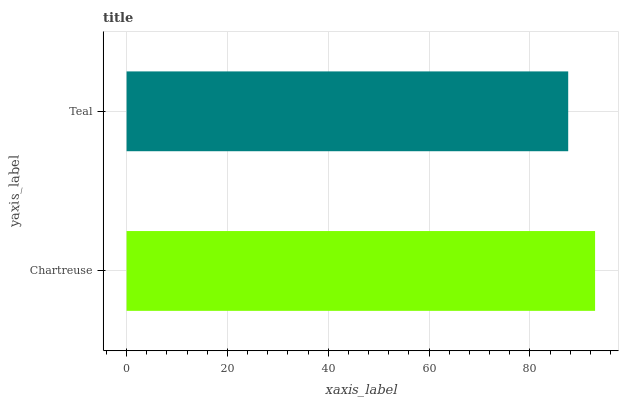Is Teal the minimum?
Answer yes or no. Yes. Is Chartreuse the maximum?
Answer yes or no. Yes. Is Teal the maximum?
Answer yes or no. No. Is Chartreuse greater than Teal?
Answer yes or no. Yes. Is Teal less than Chartreuse?
Answer yes or no. Yes. Is Teal greater than Chartreuse?
Answer yes or no. No. Is Chartreuse less than Teal?
Answer yes or no. No. Is Chartreuse the high median?
Answer yes or no. Yes. Is Teal the low median?
Answer yes or no. Yes. Is Teal the high median?
Answer yes or no. No. Is Chartreuse the low median?
Answer yes or no. No. 